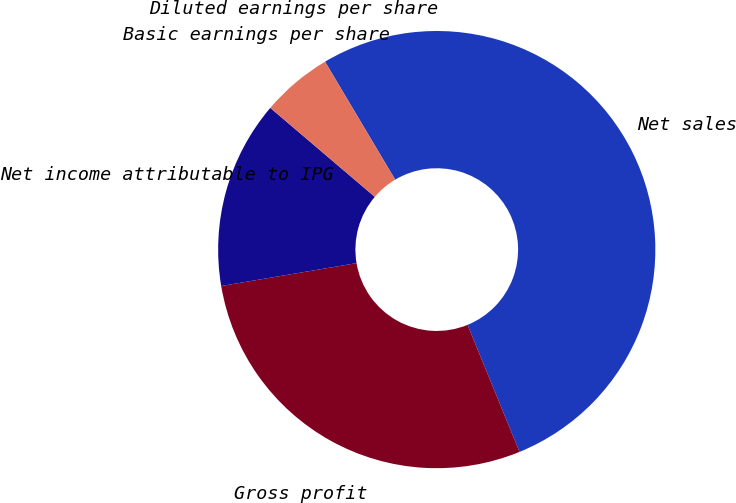<chart> <loc_0><loc_0><loc_500><loc_500><pie_chart><fcel>Net sales<fcel>Gross profit<fcel>Net income attributable to IPG<fcel>Basic earnings per share<fcel>Diluted earnings per share<nl><fcel>52.36%<fcel>28.52%<fcel>13.89%<fcel>5.24%<fcel>0.0%<nl></chart> 